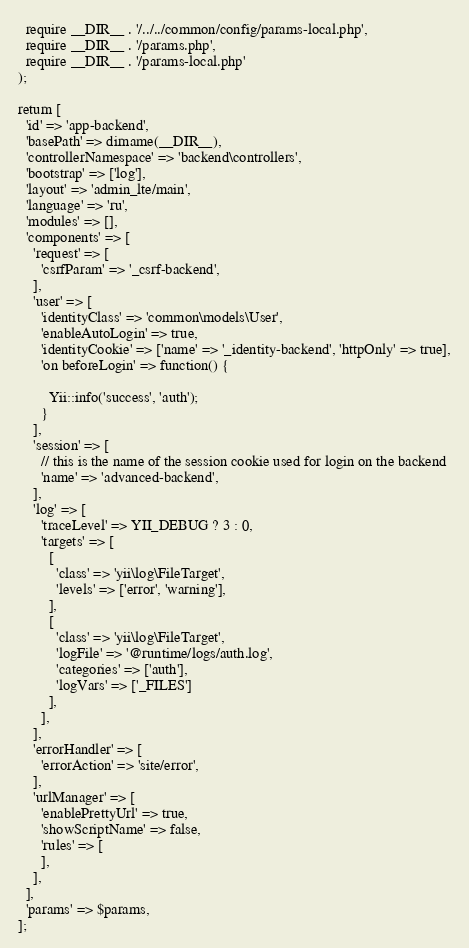<code> <loc_0><loc_0><loc_500><loc_500><_PHP_>  require __DIR__ . '/../../common/config/params-local.php',
  require __DIR__ . '/params.php',
  require __DIR__ . '/params-local.php'
);

return [
  'id' => 'app-backend',
  'basePath' => dirname(__DIR__),
  'controllerNamespace' => 'backend\controllers',
  'bootstrap' => ['log'],
  'layout' => 'admin_lte/main',
  'language' => 'ru',
  'modules' => [],
  'components' => [
    'request' => [
      'csrfParam' => '_csrf-backend',
    ],
    'user' => [
      'identityClass' => 'common\models\User',
      'enableAutoLogin' => true,
      'identityCookie' => ['name' => '_identity-backend', 'httpOnly' => true],
      'on beforeLogin' => function() {

        Yii::info('success', 'auth');
      }
    ],
    'session' => [
      // this is the name of the session cookie used for login on the backend
      'name' => 'advanced-backend',
    ],
    'log' => [
      'traceLevel' => YII_DEBUG ? 3 : 0,
      'targets' => [
        [
          'class' => 'yii\log\FileTarget',
          'levels' => ['error', 'warning'],
        ],
        [
          'class' => 'yii\log\FileTarget',
          'logFile' => '@runtime/logs/auth.log',
          'categories' => ['auth'],
          'logVars' => ['_FILES']
        ],
      ],
    ],
    'errorHandler' => [
      'errorAction' => 'site/error',
    ],
    'urlManager' => [
      'enablePrettyUrl' => true,
      'showScriptName' => false,
      'rules' => [
      ],
    ],
  ],
  'params' => $params,
];
</code> 